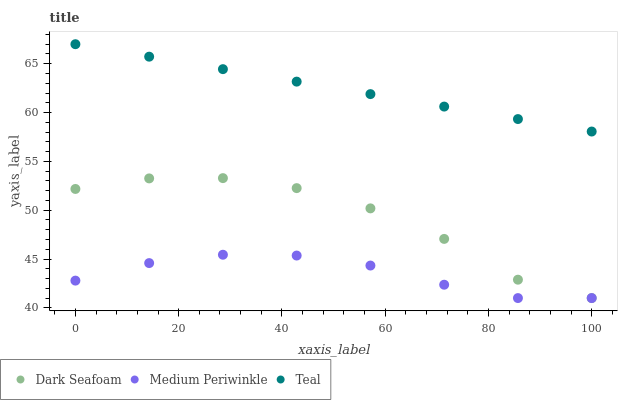Does Medium Periwinkle have the minimum area under the curve?
Answer yes or no. Yes. Does Teal have the maximum area under the curve?
Answer yes or no. Yes. Does Teal have the minimum area under the curve?
Answer yes or no. No. Does Medium Periwinkle have the maximum area under the curve?
Answer yes or no. No. Is Teal the smoothest?
Answer yes or no. Yes. Is Dark Seafoam the roughest?
Answer yes or no. Yes. Is Medium Periwinkle the smoothest?
Answer yes or no. No. Is Medium Periwinkle the roughest?
Answer yes or no. No. Does Dark Seafoam have the lowest value?
Answer yes or no. Yes. Does Teal have the lowest value?
Answer yes or no. No. Does Teal have the highest value?
Answer yes or no. Yes. Does Medium Periwinkle have the highest value?
Answer yes or no. No. Is Dark Seafoam less than Teal?
Answer yes or no. Yes. Is Teal greater than Dark Seafoam?
Answer yes or no. Yes. Does Dark Seafoam intersect Medium Periwinkle?
Answer yes or no. Yes. Is Dark Seafoam less than Medium Periwinkle?
Answer yes or no. No. Is Dark Seafoam greater than Medium Periwinkle?
Answer yes or no. No. Does Dark Seafoam intersect Teal?
Answer yes or no. No. 